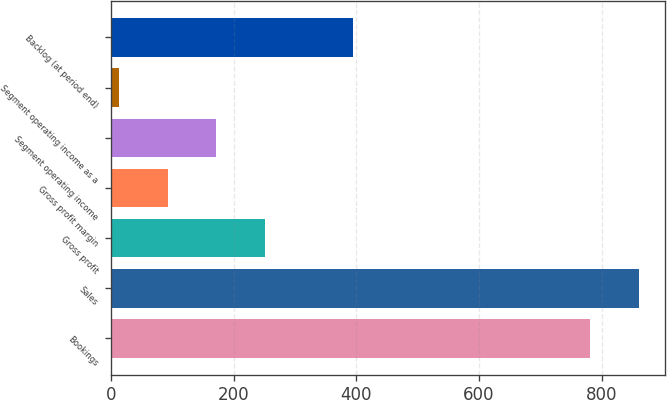Convert chart to OTSL. <chart><loc_0><loc_0><loc_500><loc_500><bar_chart><fcel>Bookings<fcel>Sales<fcel>Gross profit<fcel>Gross profit margin<fcel>Segment operating income<fcel>Segment operating income as a<fcel>Backlog (at period end)<nl><fcel>781<fcel>860.26<fcel>251.08<fcel>92.56<fcel>171.82<fcel>13.3<fcel>393.9<nl></chart> 